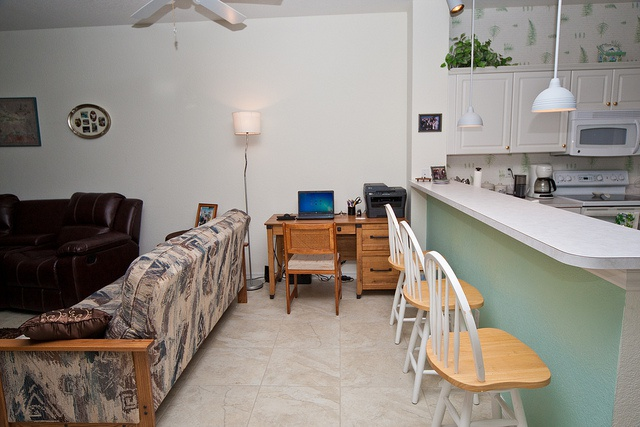Describe the objects in this image and their specific colors. I can see couch in purple, gray, and darkgray tones, couch in purple, black, gray, and darkgray tones, chair in purple, darkgray, tan, and lightgray tones, oven in purple, gray, and black tones, and chair in purple, brown, darkgray, and gray tones in this image. 